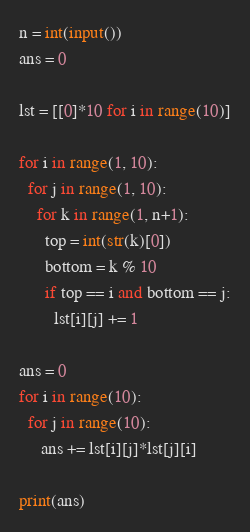<code> <loc_0><loc_0><loc_500><loc_500><_Python_>n = int(input())
ans = 0

lst = [[0]*10 for i in range(10)]

for i in range(1, 10):
  for j in range(1, 10):
    for k in range(1, n+1):
      top = int(str(k)[0])
      bottom = k % 10
      if top == i and bottom == j:
        lst[i][j] += 1

ans = 0
for i in range(10):
  for j in range(10):
     ans += lst[i][j]*lst[j][i]

print(ans)</code> 